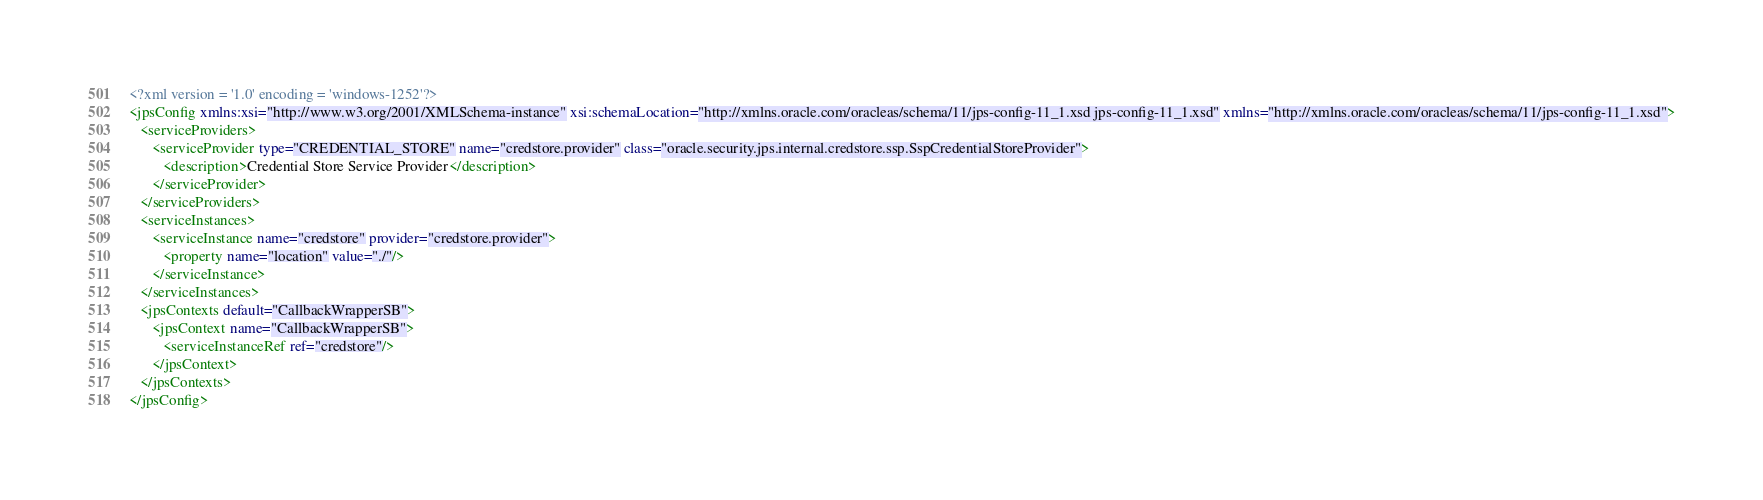<code> <loc_0><loc_0><loc_500><loc_500><_XML_><?xml version = '1.0' encoding = 'windows-1252'?>
<jpsConfig xmlns:xsi="http://www.w3.org/2001/XMLSchema-instance" xsi:schemaLocation="http://xmlns.oracle.com/oracleas/schema/11/jps-config-11_1.xsd jps-config-11_1.xsd" xmlns="http://xmlns.oracle.com/oracleas/schema/11/jps-config-11_1.xsd">
   <serviceProviders>
      <serviceProvider type="CREDENTIAL_STORE" name="credstore.provider" class="oracle.security.jps.internal.credstore.ssp.SspCredentialStoreProvider">
         <description>Credential Store Service Provider</description>
      </serviceProvider>
   </serviceProviders>
   <serviceInstances>
      <serviceInstance name="credstore" provider="credstore.provider">
         <property name="location" value="./"/>
      </serviceInstance>
   </serviceInstances>
   <jpsContexts default="CallbackWrapperSB">
      <jpsContext name="CallbackWrapperSB">
         <serviceInstanceRef ref="credstore"/>
      </jpsContext>
   </jpsContexts>
</jpsConfig></code> 